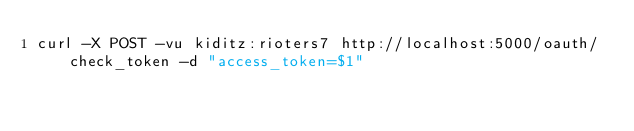Convert code to text. <code><loc_0><loc_0><loc_500><loc_500><_Bash_>curl -X POST -vu kiditz:rioters7 http://localhost:5000/oauth/check_token -d "access_token=$1"
</code> 